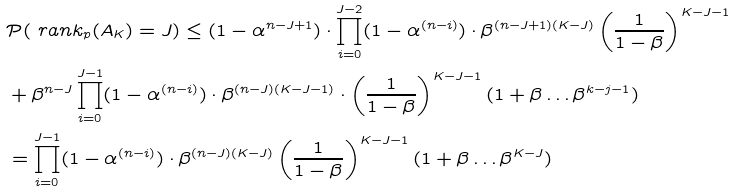<formula> <loc_0><loc_0><loc_500><loc_500>& \mathcal { P } ( \ r a n k _ { p } ( A _ { K } ) = J ) \leq ( 1 - \alpha ^ { n - J + 1 } ) \cdot \prod _ { i = 0 } ^ { J - 2 } ( 1 - \alpha ^ { ( n - i ) } ) \cdot \beta ^ { ( n - J + 1 ) ( K - J ) } \left ( \frac { 1 } { 1 - \beta } \right ) ^ { K - J - 1 } \\ & + \beta ^ { n - J } \prod _ { i = 0 } ^ { J - 1 } ( 1 - \alpha ^ { ( n - i ) } ) \cdot \beta ^ { ( n - J ) ( K - J - 1 ) } \cdot \left ( \frac { 1 } { 1 - \beta } \right ) ^ { K - J - 1 } ( 1 + \beta \dots \beta ^ { k - j - 1 } ) \\ & = \prod _ { i = 0 } ^ { J - 1 } ( 1 - \alpha ^ { ( n - i ) } ) \cdot \beta ^ { ( n - J ) ( K - J ) } \left ( \frac { 1 } { 1 - \beta } \right ) ^ { K - J - 1 } ( 1 + \beta \dots \beta ^ { K - J } )</formula> 